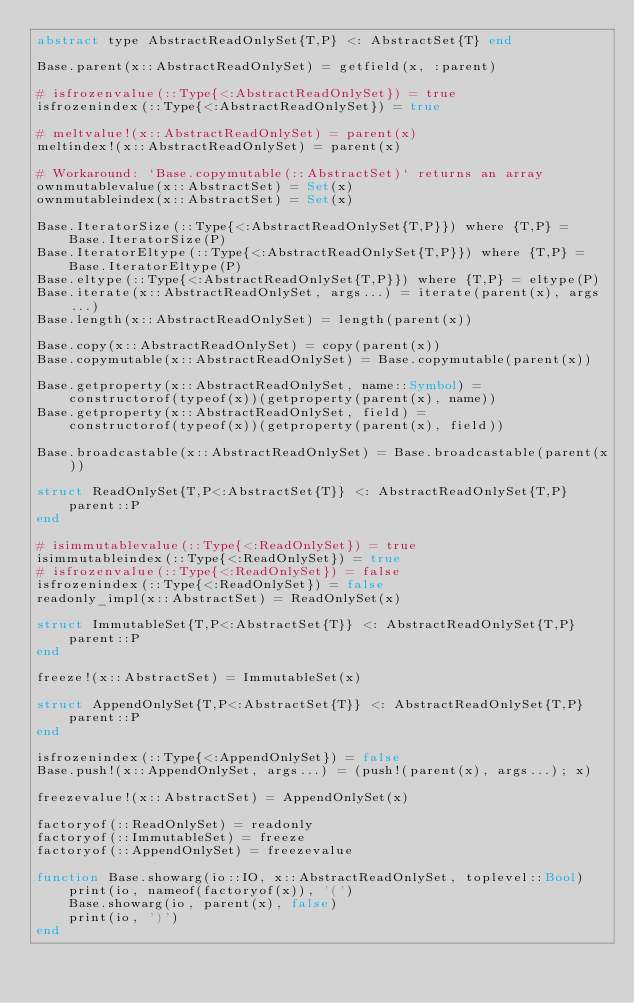Convert code to text. <code><loc_0><loc_0><loc_500><loc_500><_Julia_>abstract type AbstractReadOnlySet{T,P} <: AbstractSet{T} end

Base.parent(x::AbstractReadOnlySet) = getfield(x, :parent)

# isfrozenvalue(::Type{<:AbstractReadOnlySet}) = true
isfrozenindex(::Type{<:AbstractReadOnlySet}) = true

# meltvalue!(x::AbstractReadOnlySet) = parent(x)
meltindex!(x::AbstractReadOnlySet) = parent(x)

# Workaround: `Base.copymutable(::AbstractSet)` returns an array
ownmutablevalue(x::AbstractSet) = Set(x)
ownmutableindex(x::AbstractSet) = Set(x)

Base.IteratorSize(::Type{<:AbstractReadOnlySet{T,P}}) where {T,P} =
    Base.IteratorSize(P)
Base.IteratorEltype(::Type{<:AbstractReadOnlySet{T,P}}) where {T,P} =
    Base.IteratorEltype(P)
Base.eltype(::Type{<:AbstractReadOnlySet{T,P}}) where {T,P} = eltype(P)
Base.iterate(x::AbstractReadOnlySet, args...) = iterate(parent(x), args...)
Base.length(x::AbstractReadOnlySet) = length(parent(x))

Base.copy(x::AbstractReadOnlySet) = copy(parent(x))
Base.copymutable(x::AbstractReadOnlySet) = Base.copymutable(parent(x))

Base.getproperty(x::AbstractReadOnlySet, name::Symbol) =
    constructorof(typeof(x))(getproperty(parent(x), name))
Base.getproperty(x::AbstractReadOnlySet, field) =
    constructorof(typeof(x))(getproperty(parent(x), field))

Base.broadcastable(x::AbstractReadOnlySet) = Base.broadcastable(parent(x))

struct ReadOnlySet{T,P<:AbstractSet{T}} <: AbstractReadOnlySet{T,P}
    parent::P
end

# isimmutablevalue(::Type{<:ReadOnlySet}) = true
isimmutableindex(::Type{<:ReadOnlySet}) = true
# isfrozenvalue(::Type{<:ReadOnlySet}) = false
isfrozenindex(::Type{<:ReadOnlySet}) = false
readonly_impl(x::AbstractSet) = ReadOnlySet(x)

struct ImmutableSet{T,P<:AbstractSet{T}} <: AbstractReadOnlySet{T,P}
    parent::P
end

freeze!(x::AbstractSet) = ImmutableSet(x)

struct AppendOnlySet{T,P<:AbstractSet{T}} <: AbstractReadOnlySet{T,P}
    parent::P
end

isfrozenindex(::Type{<:AppendOnlySet}) = false
Base.push!(x::AppendOnlySet, args...) = (push!(parent(x), args...); x)

freezevalue!(x::AbstractSet) = AppendOnlySet(x)

factoryof(::ReadOnlySet) = readonly
factoryof(::ImmutableSet) = freeze
factoryof(::AppendOnlySet) = freezevalue

function Base.showarg(io::IO, x::AbstractReadOnlySet, toplevel::Bool)
    print(io, nameof(factoryof(x)), '(')
    Base.showarg(io, parent(x), false)
    print(io, ')')
end
</code> 